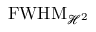<formula> <loc_0><loc_0><loc_500><loc_500>F W H M _ { \mathcal { H } ^ { 2 } }</formula> 